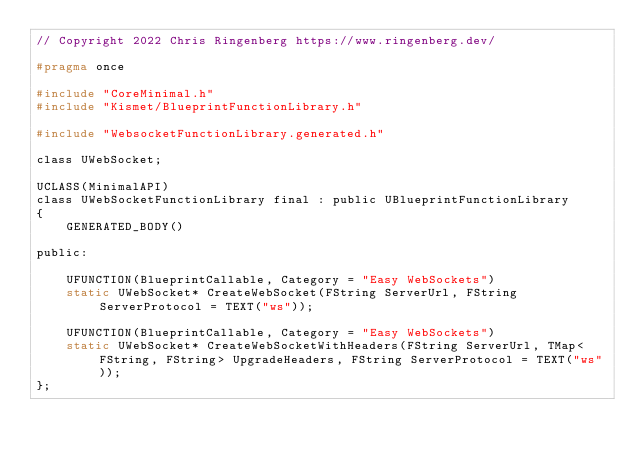<code> <loc_0><loc_0><loc_500><loc_500><_C_>// Copyright 2022 Chris Ringenberg https://www.ringenberg.dev/

#pragma once

#include "CoreMinimal.h"
#include "Kismet/BlueprintFunctionLibrary.h"

#include "WebsocketFunctionLibrary.generated.h"

class UWebSocket;

UCLASS(MinimalAPI)
class UWebSocketFunctionLibrary final : public UBlueprintFunctionLibrary
{
	GENERATED_BODY()

public:

	UFUNCTION(BlueprintCallable, Category = "Easy WebSockets")
	static UWebSocket* CreateWebSocket(FString ServerUrl, FString ServerProtocol = TEXT("ws"));

	UFUNCTION(BlueprintCallable, Category = "Easy WebSockets")
	static UWebSocket* CreateWebSocketWithHeaders(FString ServerUrl, TMap<FString, FString> UpgradeHeaders, FString ServerProtocol = TEXT("ws"));
};</code> 